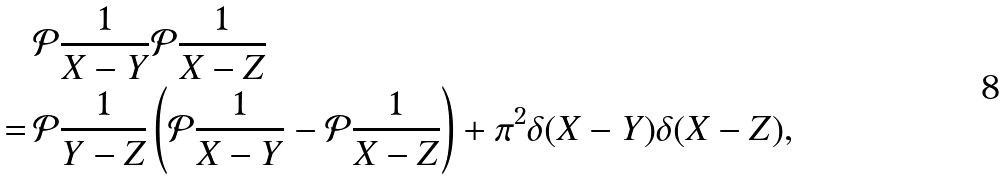<formula> <loc_0><loc_0><loc_500><loc_500>& \mathcal { P } \frac { 1 } { X - Y } \mathcal { P } \frac { 1 } { X - Z } \\ = \, & \mathcal { P } \frac { 1 } { Y - Z } \left ( \mathcal { P } \frac { 1 } { X - Y } - \mathcal { P } \frac { 1 } { X - Z } \right ) + \pi ^ { 2 } \delta ( X - Y ) \delta ( X - Z ) ,</formula> 